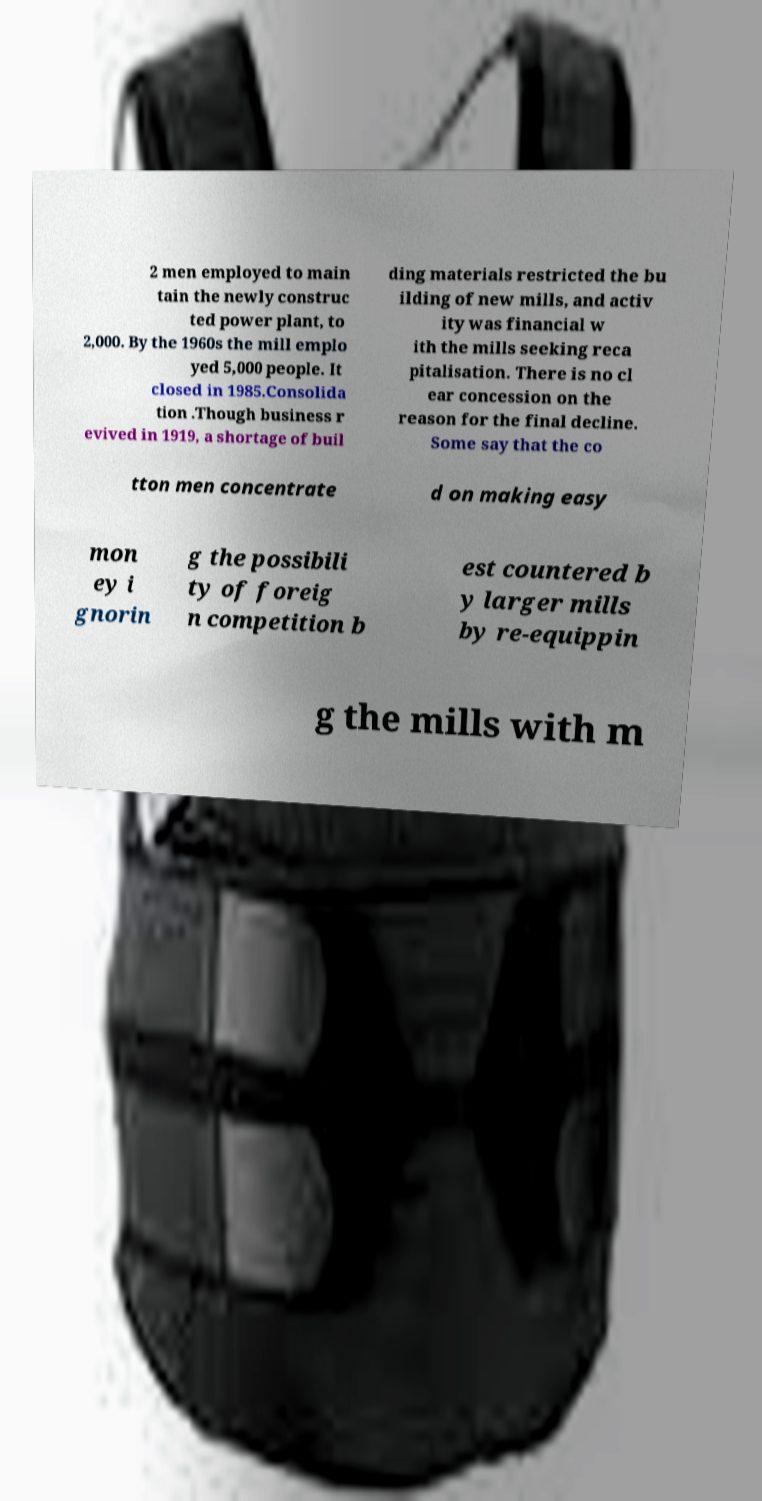Please read and relay the text visible in this image. What does it say? 2 men employed to main tain the newly construc ted power plant, to 2,000. By the 1960s the mill emplo yed 5,000 people. It closed in 1985.Consolida tion .Though business r evived in 1919, a shortage of buil ding materials restricted the bu ilding of new mills, and activ ity was financial w ith the mills seeking reca pitalisation. There is no cl ear concession on the reason for the final decline. Some say that the co tton men concentrate d on making easy mon ey i gnorin g the possibili ty of foreig n competition b est countered b y larger mills by re-equippin g the mills with m 